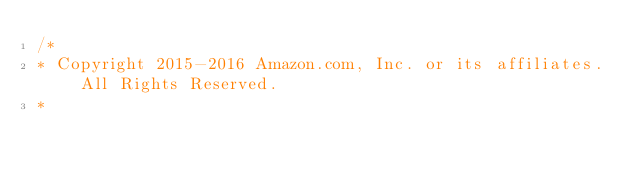<code> <loc_0><loc_0><loc_500><loc_500><_JavaScript_>/*
* Copyright 2015-2016 Amazon.com, Inc. or its affiliates. All Rights Reserved.
*</code> 